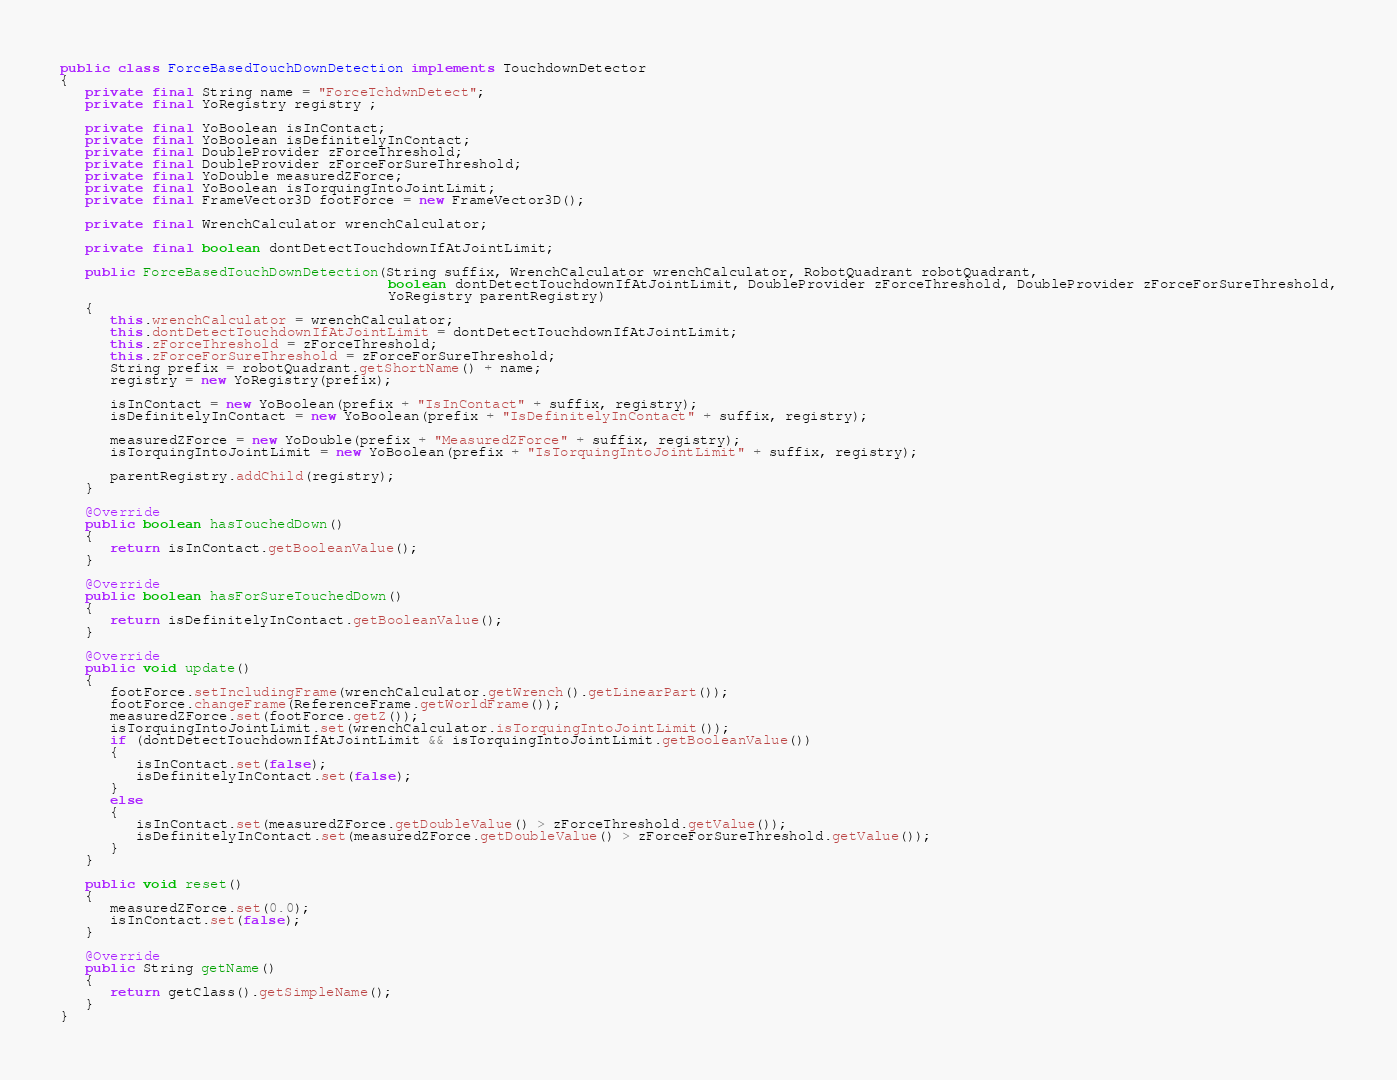<code> <loc_0><loc_0><loc_500><loc_500><_Java_>
public class ForceBasedTouchDownDetection implements TouchdownDetector
{
   private final String name = "ForceTchdwnDetect";
   private final YoRegistry registry ;

   private final YoBoolean isInContact;
   private final YoBoolean isDefinitelyInContact;
   private final DoubleProvider zForceThreshold;
   private final DoubleProvider zForceForSureThreshold;
   private final YoDouble measuredZForce;
   private final YoBoolean isTorquingIntoJointLimit;
   private final FrameVector3D footForce = new FrameVector3D();

   private final WrenchCalculator wrenchCalculator;

   private final boolean dontDetectTouchdownIfAtJointLimit;

   public ForceBasedTouchDownDetection(String suffix, WrenchCalculator wrenchCalculator, RobotQuadrant robotQuadrant,
                                       boolean dontDetectTouchdownIfAtJointLimit, DoubleProvider zForceThreshold, DoubleProvider zForceForSureThreshold,
                                       YoRegistry parentRegistry)
   {
      this.wrenchCalculator = wrenchCalculator;
      this.dontDetectTouchdownIfAtJointLimit = dontDetectTouchdownIfAtJointLimit;
      this.zForceThreshold = zForceThreshold;
      this.zForceForSureThreshold = zForceForSureThreshold;
      String prefix = robotQuadrant.getShortName() + name;
      registry = new YoRegistry(prefix);

      isInContact = new YoBoolean(prefix + "IsInContact" + suffix, registry);
      isDefinitelyInContact = new YoBoolean(prefix + "IsDefinitelyInContact" + suffix, registry);

      measuredZForce = new YoDouble(prefix + "MeasuredZForce" + suffix, registry);
      isTorquingIntoJointLimit = new YoBoolean(prefix + "IsTorquingIntoJointLimit" + suffix, registry);

      parentRegistry.addChild(registry);
   }

   @Override
   public boolean hasTouchedDown()
   {
      return isInContact.getBooleanValue();
   }

   @Override
   public boolean hasForSureTouchedDown()
   {
      return isDefinitelyInContact.getBooleanValue();
   }

   @Override
   public void update()
   {
      footForce.setIncludingFrame(wrenchCalculator.getWrench().getLinearPart());
      footForce.changeFrame(ReferenceFrame.getWorldFrame());
      measuredZForce.set(footForce.getZ());
      isTorquingIntoJointLimit.set(wrenchCalculator.isTorquingIntoJointLimit());
      if (dontDetectTouchdownIfAtJointLimit && isTorquingIntoJointLimit.getBooleanValue())
      {
         isInContact.set(false);
         isDefinitelyInContact.set(false);
      }
      else
      {
         isInContact.set(measuredZForce.getDoubleValue() > zForceThreshold.getValue());
         isDefinitelyInContact.set(measuredZForce.getDoubleValue() > zForceForSureThreshold.getValue());
      }
   }

   public void reset()
   {
      measuredZForce.set(0.0);
      isInContact.set(false);
   }

   @Override
   public String getName()
   {
      return getClass().getSimpleName();
   }
}
</code> 